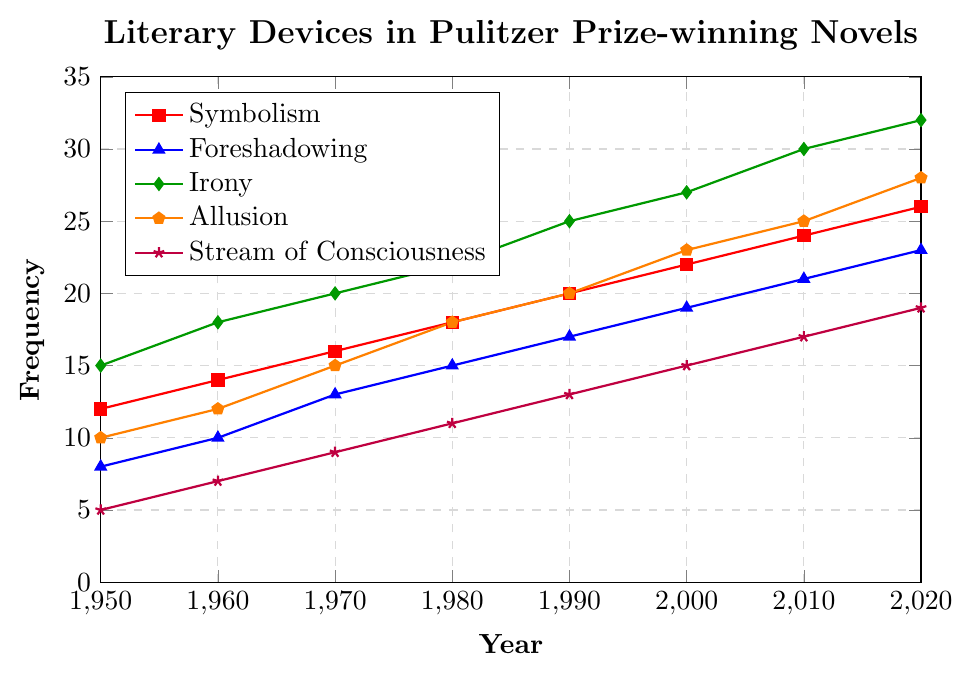What has been the general trend of the frequency of symbolism from 1950 to 2020? By observing the plot, we see that the data points for Symbolism (represented by red squares) show a consistent upward trend from 12 in 1950 to 26 in 2020. This indicates an increasing trend.
Answer: Increasing Which literary device had the highest frequency in 2020? We check the data points for each literary device in 2020 and see that Irony (green diamonds) had the highest frequency with a value of 32.
Answer: Irony How did the frequency of Allusion in 1980 compare to that of Symbolism in the same year? From the plot, the frequency of Allusion (orange pentagons) in 1980 is 18, while the frequency of Symbolism (red squares) in 1980 is also 18. Therefore, they are equal.
Answer: Equal What is the difference between the frequency of Stream of Consciousness in 2020 and 1950? The frequency of Stream of Consciousness in 2020 is 19, and in 1950 it is 5. The difference is calculated as 19 - 5 = 14.
Answer: 14 Which year showed a higher increase in foreshadowing frequency compared to the previous decade: 1980 or 1990? Foreshadowing frequency in 1980 is 15 and in 1970 it is 13, making a difference of 2. In 1990, the frequency is 17 and in 1980 it is 15, making a difference of 2 as well. Both years show the same increase.
Answer: Same In what year did Irony reach a frequency of 30? By examining the plot, we see that Irony (green diamonds) reached a frequency of 30 in the year 2010.
Answer: 2010 If you were to average the frequency of foreshadowing and symbolism in 1960, what would the value be? The frequency of foreshadowing in 1960 is 10, and symbolism is 14. The average is calculated as (10 + 14) / 2 = 12.
Answer: 12 Identify the visual attribute (color) of the plot line representing Stream of Consciousness. By looking at the plot, the line representing Stream of Consciousness is indicated with purple stars.
Answer: Purple Combining Allusion and Irony, what is their total frequency in 2000? In 2000, the frequency of Allusion is 23, and Irony is 27. The combined total is 23 + 27 = 50.
Answer: 50 